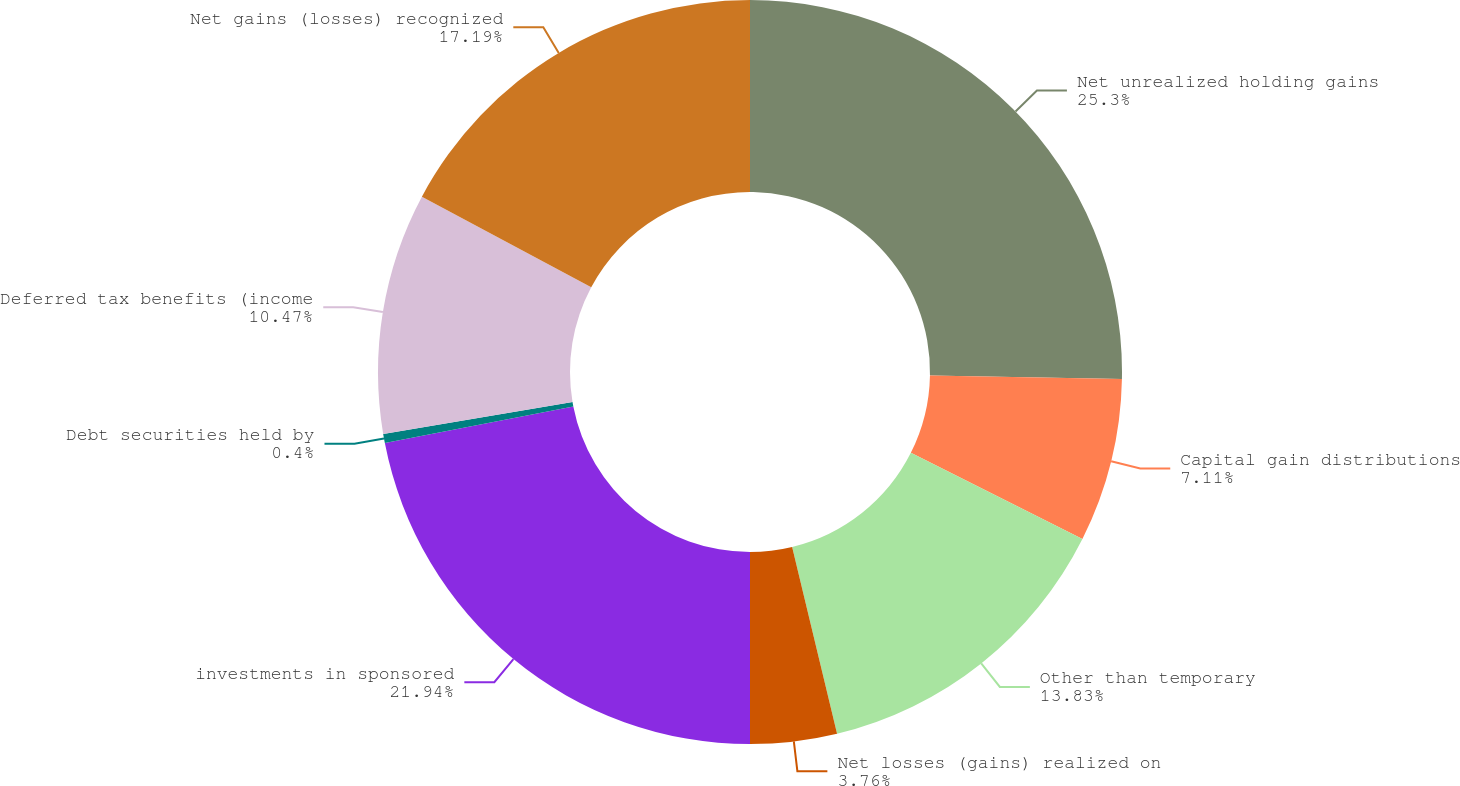Convert chart. <chart><loc_0><loc_0><loc_500><loc_500><pie_chart><fcel>Net unrealized holding gains<fcel>Capital gain distributions<fcel>Other than temporary<fcel>Net losses (gains) realized on<fcel>investments in sponsored<fcel>Debt securities held by<fcel>Deferred tax benefits (income<fcel>Net gains (losses) recognized<nl><fcel>25.3%<fcel>7.11%<fcel>13.83%<fcel>3.76%<fcel>21.94%<fcel>0.4%<fcel>10.47%<fcel>17.19%<nl></chart> 